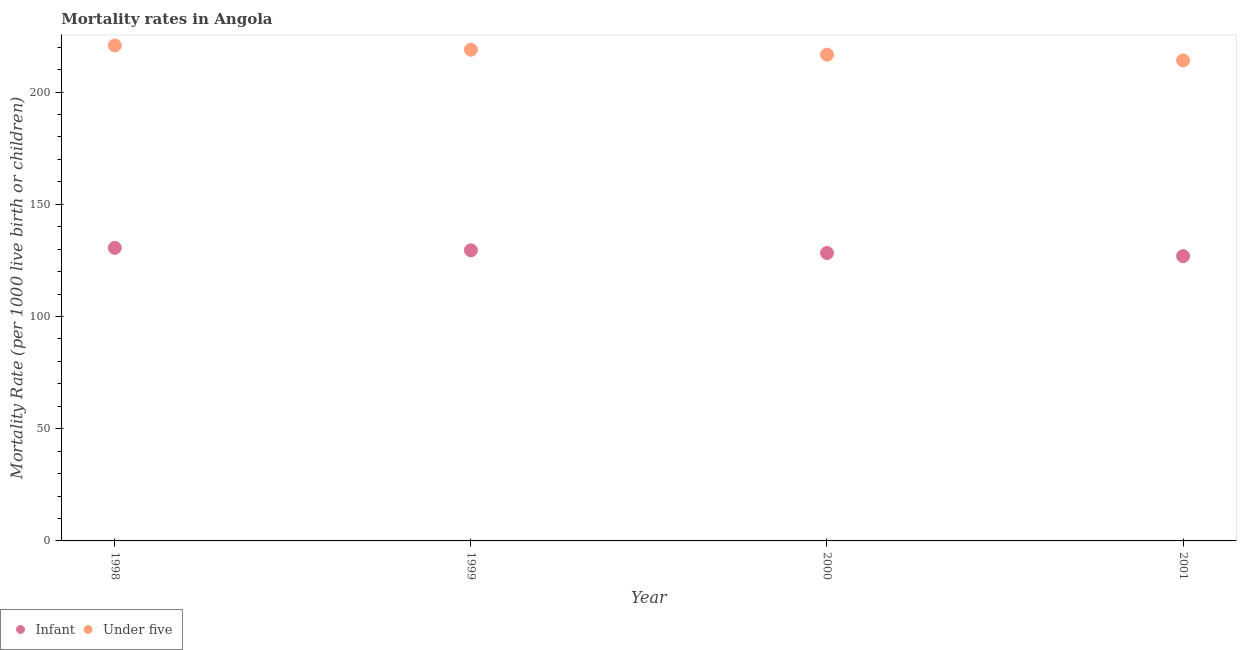How many different coloured dotlines are there?
Offer a very short reply. 2. What is the under-5 mortality rate in 2001?
Your answer should be compact. 214.1. Across all years, what is the maximum infant mortality rate?
Give a very brief answer. 130.6. Across all years, what is the minimum infant mortality rate?
Offer a terse response. 126.9. In which year was the under-5 mortality rate minimum?
Offer a terse response. 2001. What is the total infant mortality rate in the graph?
Make the answer very short. 515.3. What is the difference between the infant mortality rate in 1998 and that in 2001?
Your answer should be very brief. 3.7. What is the difference between the infant mortality rate in 1999 and the under-5 mortality rate in 1998?
Ensure brevity in your answer.  -91.3. What is the average infant mortality rate per year?
Offer a terse response. 128.83. In the year 1998, what is the difference between the under-5 mortality rate and infant mortality rate?
Give a very brief answer. 90.2. In how many years, is the infant mortality rate greater than 170?
Your answer should be very brief. 0. What is the ratio of the under-5 mortality rate in 1998 to that in 2000?
Offer a terse response. 1.02. Is the under-5 mortality rate in 1998 less than that in 2000?
Offer a very short reply. No. Is the difference between the infant mortality rate in 1998 and 2001 greater than the difference between the under-5 mortality rate in 1998 and 2001?
Your answer should be compact. No. What is the difference between the highest and the second highest under-5 mortality rate?
Provide a succinct answer. 1.9. What is the difference between the highest and the lowest under-5 mortality rate?
Provide a short and direct response. 6.7. In how many years, is the under-5 mortality rate greater than the average under-5 mortality rate taken over all years?
Your answer should be compact. 2. Is the sum of the under-5 mortality rate in 1998 and 2001 greater than the maximum infant mortality rate across all years?
Your answer should be very brief. Yes. Does the under-5 mortality rate monotonically increase over the years?
Offer a very short reply. No. Are the values on the major ticks of Y-axis written in scientific E-notation?
Give a very brief answer. No. Where does the legend appear in the graph?
Give a very brief answer. Bottom left. How many legend labels are there?
Your answer should be compact. 2. What is the title of the graph?
Your answer should be very brief. Mortality rates in Angola. Does "Urban" appear as one of the legend labels in the graph?
Keep it short and to the point. No. What is the label or title of the X-axis?
Offer a very short reply. Year. What is the label or title of the Y-axis?
Your answer should be compact. Mortality Rate (per 1000 live birth or children). What is the Mortality Rate (per 1000 live birth or children) in Infant in 1998?
Provide a succinct answer. 130.6. What is the Mortality Rate (per 1000 live birth or children) of Under five in 1998?
Keep it short and to the point. 220.8. What is the Mortality Rate (per 1000 live birth or children) of Infant in 1999?
Keep it short and to the point. 129.5. What is the Mortality Rate (per 1000 live birth or children) of Under five in 1999?
Your response must be concise. 218.9. What is the Mortality Rate (per 1000 live birth or children) of Infant in 2000?
Ensure brevity in your answer.  128.3. What is the Mortality Rate (per 1000 live birth or children) of Under five in 2000?
Provide a short and direct response. 216.7. What is the Mortality Rate (per 1000 live birth or children) of Infant in 2001?
Keep it short and to the point. 126.9. What is the Mortality Rate (per 1000 live birth or children) of Under five in 2001?
Give a very brief answer. 214.1. Across all years, what is the maximum Mortality Rate (per 1000 live birth or children) of Infant?
Offer a very short reply. 130.6. Across all years, what is the maximum Mortality Rate (per 1000 live birth or children) in Under five?
Offer a very short reply. 220.8. Across all years, what is the minimum Mortality Rate (per 1000 live birth or children) in Infant?
Keep it short and to the point. 126.9. Across all years, what is the minimum Mortality Rate (per 1000 live birth or children) in Under five?
Provide a short and direct response. 214.1. What is the total Mortality Rate (per 1000 live birth or children) in Infant in the graph?
Offer a very short reply. 515.3. What is the total Mortality Rate (per 1000 live birth or children) in Under five in the graph?
Your response must be concise. 870.5. What is the difference between the Mortality Rate (per 1000 live birth or children) in Infant in 1998 and that in 1999?
Provide a short and direct response. 1.1. What is the difference between the Mortality Rate (per 1000 live birth or children) in Under five in 1998 and that in 1999?
Ensure brevity in your answer.  1.9. What is the difference between the Mortality Rate (per 1000 live birth or children) in Infant in 1998 and that in 2000?
Keep it short and to the point. 2.3. What is the difference between the Mortality Rate (per 1000 live birth or children) in Under five in 1998 and that in 2001?
Offer a very short reply. 6.7. What is the difference between the Mortality Rate (per 1000 live birth or children) in Infant in 1999 and that in 2000?
Make the answer very short. 1.2. What is the difference between the Mortality Rate (per 1000 live birth or children) of Infant in 1999 and that in 2001?
Keep it short and to the point. 2.6. What is the difference between the Mortality Rate (per 1000 live birth or children) in Under five in 1999 and that in 2001?
Your answer should be very brief. 4.8. What is the difference between the Mortality Rate (per 1000 live birth or children) in Under five in 2000 and that in 2001?
Your response must be concise. 2.6. What is the difference between the Mortality Rate (per 1000 live birth or children) of Infant in 1998 and the Mortality Rate (per 1000 live birth or children) of Under five in 1999?
Give a very brief answer. -88.3. What is the difference between the Mortality Rate (per 1000 live birth or children) of Infant in 1998 and the Mortality Rate (per 1000 live birth or children) of Under five in 2000?
Provide a short and direct response. -86.1. What is the difference between the Mortality Rate (per 1000 live birth or children) in Infant in 1998 and the Mortality Rate (per 1000 live birth or children) in Under five in 2001?
Provide a succinct answer. -83.5. What is the difference between the Mortality Rate (per 1000 live birth or children) of Infant in 1999 and the Mortality Rate (per 1000 live birth or children) of Under five in 2000?
Provide a succinct answer. -87.2. What is the difference between the Mortality Rate (per 1000 live birth or children) of Infant in 1999 and the Mortality Rate (per 1000 live birth or children) of Under five in 2001?
Ensure brevity in your answer.  -84.6. What is the difference between the Mortality Rate (per 1000 live birth or children) of Infant in 2000 and the Mortality Rate (per 1000 live birth or children) of Under five in 2001?
Offer a very short reply. -85.8. What is the average Mortality Rate (per 1000 live birth or children) of Infant per year?
Make the answer very short. 128.82. What is the average Mortality Rate (per 1000 live birth or children) in Under five per year?
Offer a terse response. 217.62. In the year 1998, what is the difference between the Mortality Rate (per 1000 live birth or children) of Infant and Mortality Rate (per 1000 live birth or children) of Under five?
Make the answer very short. -90.2. In the year 1999, what is the difference between the Mortality Rate (per 1000 live birth or children) of Infant and Mortality Rate (per 1000 live birth or children) of Under five?
Give a very brief answer. -89.4. In the year 2000, what is the difference between the Mortality Rate (per 1000 live birth or children) of Infant and Mortality Rate (per 1000 live birth or children) of Under five?
Offer a very short reply. -88.4. In the year 2001, what is the difference between the Mortality Rate (per 1000 live birth or children) of Infant and Mortality Rate (per 1000 live birth or children) of Under five?
Keep it short and to the point. -87.2. What is the ratio of the Mortality Rate (per 1000 live birth or children) of Infant in 1998 to that in 1999?
Your response must be concise. 1.01. What is the ratio of the Mortality Rate (per 1000 live birth or children) of Under five in 1998 to that in 1999?
Provide a short and direct response. 1.01. What is the ratio of the Mortality Rate (per 1000 live birth or children) in Infant in 1998 to that in 2000?
Ensure brevity in your answer.  1.02. What is the ratio of the Mortality Rate (per 1000 live birth or children) of Under five in 1998 to that in 2000?
Provide a succinct answer. 1.02. What is the ratio of the Mortality Rate (per 1000 live birth or children) of Infant in 1998 to that in 2001?
Offer a terse response. 1.03. What is the ratio of the Mortality Rate (per 1000 live birth or children) in Under five in 1998 to that in 2001?
Your answer should be compact. 1.03. What is the ratio of the Mortality Rate (per 1000 live birth or children) in Infant in 1999 to that in 2000?
Keep it short and to the point. 1.01. What is the ratio of the Mortality Rate (per 1000 live birth or children) in Under five in 1999 to that in 2000?
Provide a succinct answer. 1.01. What is the ratio of the Mortality Rate (per 1000 live birth or children) in Infant in 1999 to that in 2001?
Provide a short and direct response. 1.02. What is the ratio of the Mortality Rate (per 1000 live birth or children) of Under five in 1999 to that in 2001?
Give a very brief answer. 1.02. What is the ratio of the Mortality Rate (per 1000 live birth or children) in Under five in 2000 to that in 2001?
Ensure brevity in your answer.  1.01. What is the difference between the highest and the second highest Mortality Rate (per 1000 live birth or children) of Under five?
Offer a terse response. 1.9. What is the difference between the highest and the lowest Mortality Rate (per 1000 live birth or children) in Under five?
Ensure brevity in your answer.  6.7. 